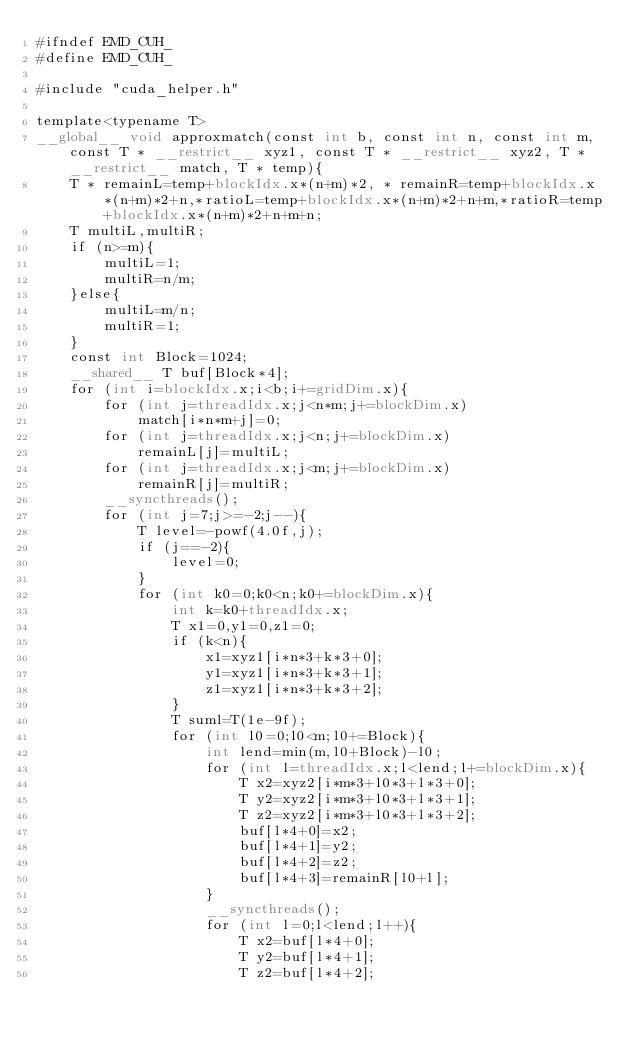<code> <loc_0><loc_0><loc_500><loc_500><_Cuda_>#ifndef EMD_CUH_
#define EMD_CUH_

#include "cuda_helper.h"

template<typename T>
__global__ void approxmatch(const int b, const int n, const int m, const T * __restrict__ xyz1, const T * __restrict__ xyz2, T * __restrict__ match, T * temp){
	T * remainL=temp+blockIdx.x*(n+m)*2, * remainR=temp+blockIdx.x*(n+m)*2+n,*ratioL=temp+blockIdx.x*(n+m)*2+n+m,*ratioR=temp+blockIdx.x*(n+m)*2+n+m+n;
	T multiL,multiR;
	if (n>=m){
		multiL=1;
		multiR=n/m;
	}else{
		multiL=m/n;
		multiR=1;
	}
	const int Block=1024;
	__shared__ T buf[Block*4];
	for (int i=blockIdx.x;i<b;i+=gridDim.x){
		for (int j=threadIdx.x;j<n*m;j+=blockDim.x)
			match[i*n*m+j]=0;
		for (int j=threadIdx.x;j<n;j+=blockDim.x)
			remainL[j]=multiL;
		for (int j=threadIdx.x;j<m;j+=blockDim.x)
			remainR[j]=multiR;
		__syncthreads();
		for (int j=7;j>=-2;j--){
			T level=-powf(4.0f,j);
			if (j==-2){
				level=0;
			}
			for (int k0=0;k0<n;k0+=blockDim.x){
				int k=k0+threadIdx.x;
				T x1=0,y1=0,z1=0;
				if (k<n){
					x1=xyz1[i*n*3+k*3+0];
					y1=xyz1[i*n*3+k*3+1];
					z1=xyz1[i*n*3+k*3+2];
				}
				T suml=T(1e-9f);
				for (int l0=0;l0<m;l0+=Block){
					int lend=min(m,l0+Block)-l0;
					for (int l=threadIdx.x;l<lend;l+=blockDim.x){
						T x2=xyz2[i*m*3+l0*3+l*3+0];
						T y2=xyz2[i*m*3+l0*3+l*3+1];
						T z2=xyz2[i*m*3+l0*3+l*3+2];
						buf[l*4+0]=x2;
						buf[l*4+1]=y2;
						buf[l*4+2]=z2;
						buf[l*4+3]=remainR[l0+l];
					}
					__syncthreads();
					for (int l=0;l<lend;l++){
						T x2=buf[l*4+0];
						T y2=buf[l*4+1];
						T z2=buf[l*4+2];</code> 